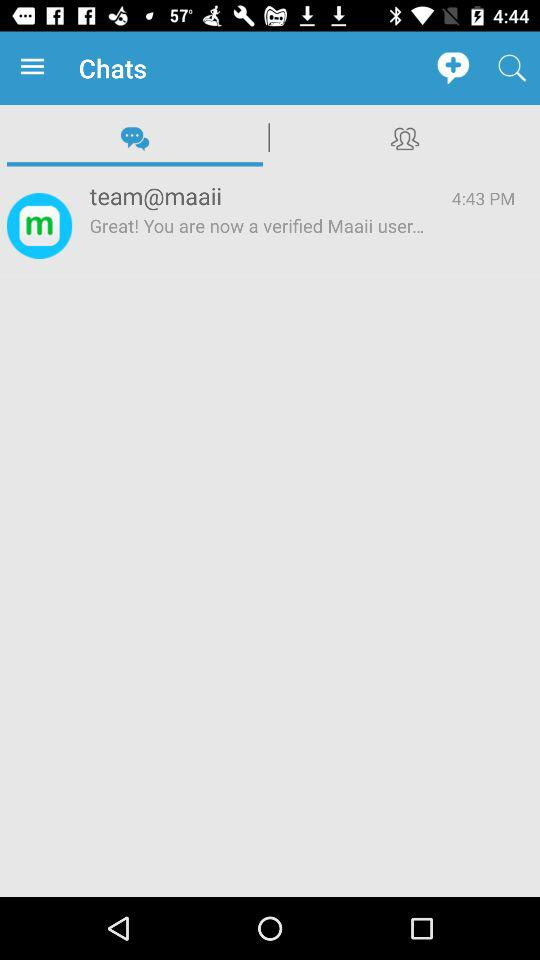Which tab has been selected? The selected tab is "Chats". 